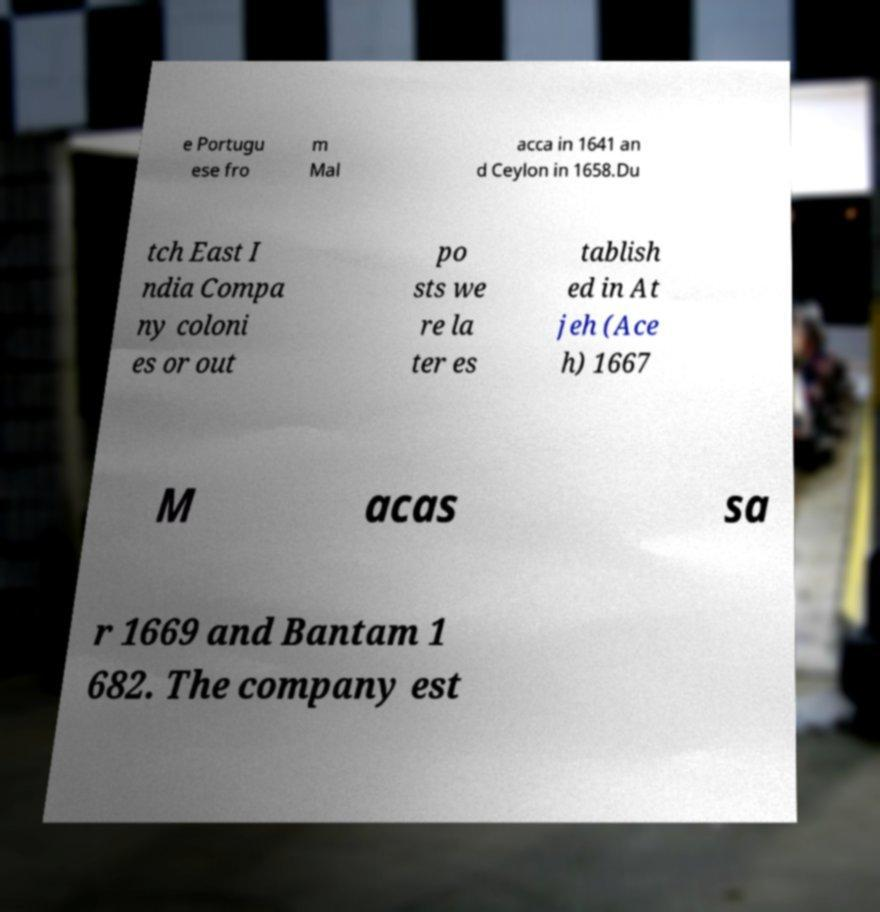For documentation purposes, I need the text within this image transcribed. Could you provide that? e Portugu ese fro m Mal acca in 1641 an d Ceylon in 1658.Du tch East I ndia Compa ny coloni es or out po sts we re la ter es tablish ed in At jeh (Ace h) 1667 M acas sa r 1669 and Bantam 1 682. The company est 